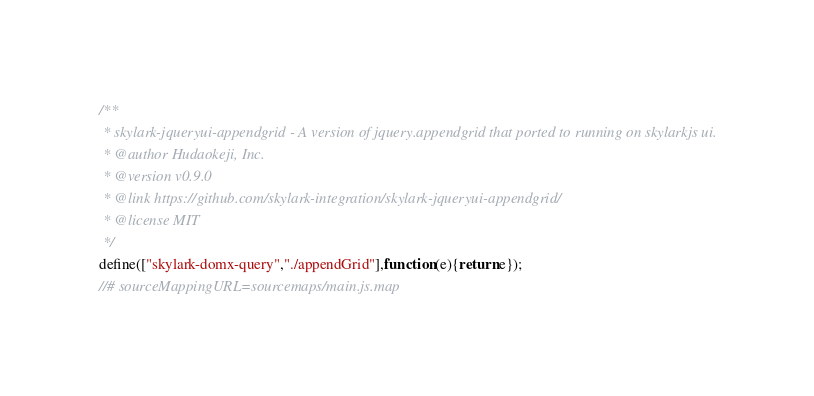Convert code to text. <code><loc_0><loc_0><loc_500><loc_500><_JavaScript_>/**
 * skylark-jqueryui-appendgrid - A version of jquery.appendgrid that ported to running on skylarkjs ui.
 * @author Hudaokeji, Inc.
 * @version v0.9.0
 * @link https://github.com/skylark-integration/skylark-jqueryui-appendgrid/
 * @license MIT
 */
define(["skylark-domx-query","./appendGrid"],function(e){return e});
//# sourceMappingURL=sourcemaps/main.js.map
</code> 